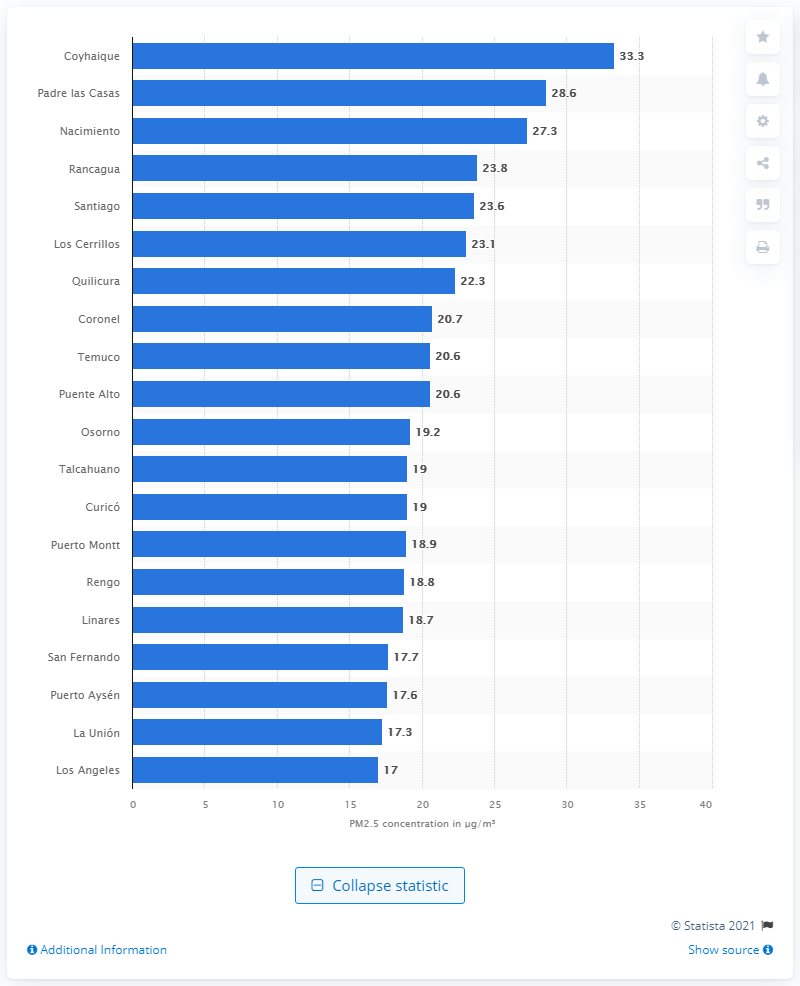Mention a couple of crucial points in this snapshot. Chile's capital is Santiago. 